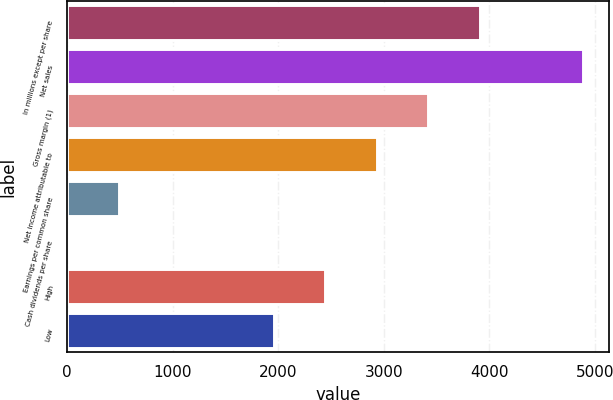Convert chart to OTSL. <chart><loc_0><loc_0><loc_500><loc_500><bar_chart><fcel>In millions except per share<fcel>Net sales<fcel>Gross margin (1)<fcel>Net income attributable to<fcel>Earnings per common share<fcel>Cash dividends per share<fcel>High<fcel>Low<nl><fcel>3912.14<fcel>4890<fcel>3423.22<fcel>2934.3<fcel>489.7<fcel>0.78<fcel>2445.38<fcel>1956.46<nl></chart> 